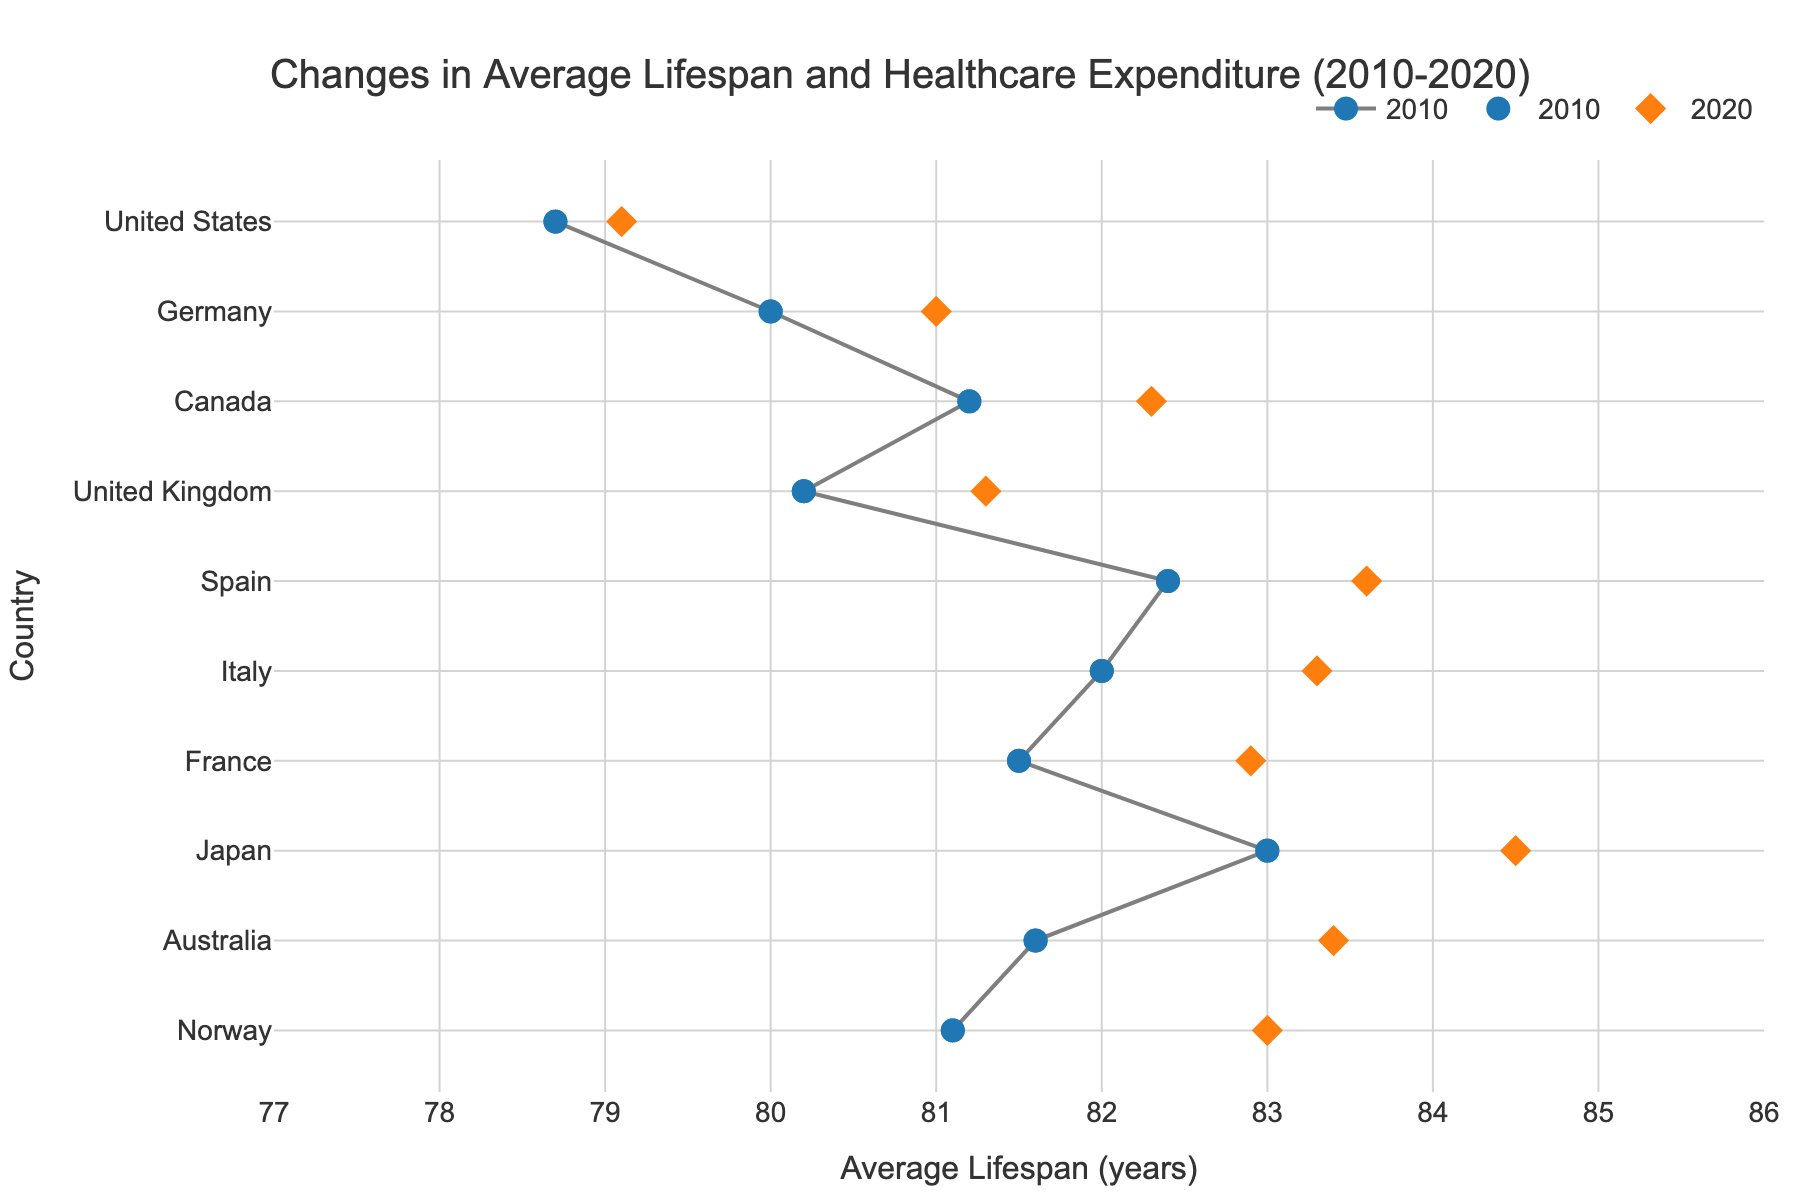What is the title of the figure? The title of the figure is usually placed at the top and often in a larger or bold font, making it easily identifiable.
Answer: "Changes in Average Lifespan and Healthcare Expenditure (2010-2020)" How many countries are represented in the figure? To determine the number of countries, one needs to count the unique rows or markers along the y-axis of the graph.
Answer: 10 What are the two years compared in the figure? The years compared can be identified by looking at the labels in the legend or the hover text for the points.
Answer: 2010 and 2020 Which country showed the greatest increase in average lifespan between 2010 and 2020? To find this, look for the dumbbell with the longest line, indicating the largest vertical difference between the position of the 2010 and 2020 markers.
Answer: Japan Which country had the smallest increase in average lifespan? This can be identified by finding the shortest line connecting the 2010 and 2020 markers for each country.
Answer: United States How does the healthcare expenditure per capita for Norway in 2020 compare to other countries? By hovering over the 2020 marker for Norway and observing its healthcare expenditure, you compare it with the expenditures of other countries' 2020 markers.
Answer: It is the highest in 2020 What is the average increase in healthcare expenditure per capita from 2010 to 2020 for all countries? Summing the healthcare expenditure values for all countries for both years, then finding the difference, and averaging it by dividing by the number of countries.
Answer: (10345-7960 + 4779-3280 + 4823-3273 + 6104-4638 + 5069-4139 + 5368-4420 + 5166-4203 + 3502-3211 + 3475-3012 + 10911-9495) / 10 = 1771 How does the lifespan of the United States in 2020 compare to the lifespan of Japan in 2010? By locating the 2020 lifespan marker for the United States and the 2010 lifespan marker for Japan and comparing their positions horizontally on the x-axis.
Answer: The lifespan in Japan in 2010 (83.0 years) is higher than that in the United States in 2020 (79.1 years) What is the difference in average lifespan between 2010 and 2020 for France? To find this, subtract the 2010 value from the 2020 value for France.
Answer: 82.9 - 81.5 = 1.4 years Which country had the highest average lifespan in 2010? Identify the country with the highest point on the x-axis for the 2010 year markers.
Answer: Japan with 83.0 years 